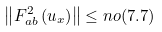<formula> <loc_0><loc_0><loc_500><loc_500>\left \| F _ { a b } ^ { 2 } \left ( u _ { x } \right ) \right \| \leq n o ( 7 . 7 )</formula> 